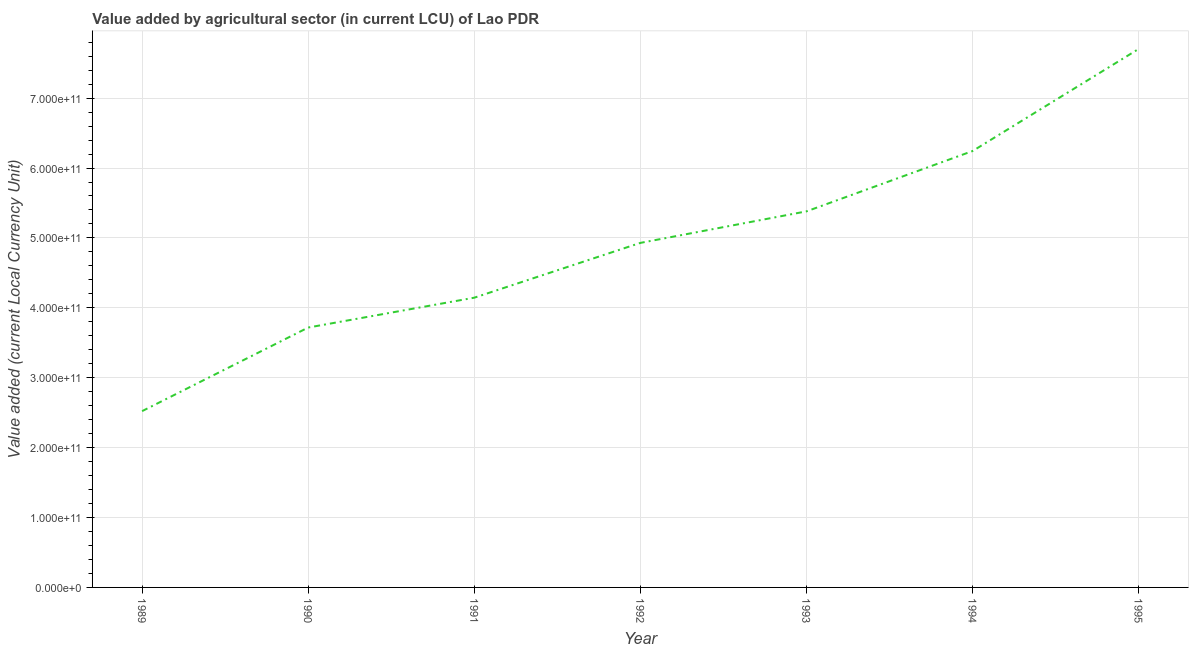What is the value added by agriculture sector in 1992?
Make the answer very short. 4.93e+11. Across all years, what is the maximum value added by agriculture sector?
Keep it short and to the point. 7.70e+11. Across all years, what is the minimum value added by agriculture sector?
Provide a short and direct response. 2.52e+11. In which year was the value added by agriculture sector maximum?
Make the answer very short. 1995. What is the sum of the value added by agriculture sector?
Provide a short and direct response. 3.46e+12. What is the difference between the value added by agriculture sector in 1989 and 1990?
Make the answer very short. -1.20e+11. What is the average value added by agriculture sector per year?
Keep it short and to the point. 4.95e+11. What is the median value added by agriculture sector?
Your answer should be very brief. 4.93e+11. In how many years, is the value added by agriculture sector greater than 420000000000 LCU?
Offer a very short reply. 4. Do a majority of the years between 1994 and 1991 (inclusive) have value added by agriculture sector greater than 100000000000 LCU?
Provide a short and direct response. Yes. What is the ratio of the value added by agriculture sector in 1989 to that in 1995?
Provide a succinct answer. 0.33. What is the difference between the highest and the second highest value added by agriculture sector?
Your answer should be very brief. 1.46e+11. Is the sum of the value added by agriculture sector in 1991 and 1993 greater than the maximum value added by agriculture sector across all years?
Keep it short and to the point. Yes. What is the difference between the highest and the lowest value added by agriculture sector?
Your response must be concise. 5.18e+11. In how many years, is the value added by agriculture sector greater than the average value added by agriculture sector taken over all years?
Your answer should be very brief. 3. How many lines are there?
Give a very brief answer. 1. What is the difference between two consecutive major ticks on the Y-axis?
Keep it short and to the point. 1.00e+11. Does the graph contain grids?
Your answer should be compact. Yes. What is the title of the graph?
Give a very brief answer. Value added by agricultural sector (in current LCU) of Lao PDR. What is the label or title of the X-axis?
Your answer should be compact. Year. What is the label or title of the Y-axis?
Your answer should be compact. Value added (current Local Currency Unit). What is the Value added (current Local Currency Unit) in 1989?
Your response must be concise. 2.52e+11. What is the Value added (current Local Currency Unit) in 1990?
Keep it short and to the point. 3.72e+11. What is the Value added (current Local Currency Unit) of 1991?
Ensure brevity in your answer.  4.14e+11. What is the Value added (current Local Currency Unit) in 1992?
Keep it short and to the point. 4.93e+11. What is the Value added (current Local Currency Unit) of 1993?
Your answer should be compact. 5.38e+11. What is the Value added (current Local Currency Unit) of 1994?
Your answer should be very brief. 6.24e+11. What is the Value added (current Local Currency Unit) in 1995?
Make the answer very short. 7.70e+11. What is the difference between the Value added (current Local Currency Unit) in 1989 and 1990?
Provide a succinct answer. -1.20e+11. What is the difference between the Value added (current Local Currency Unit) in 1989 and 1991?
Keep it short and to the point. -1.62e+11. What is the difference between the Value added (current Local Currency Unit) in 1989 and 1992?
Make the answer very short. -2.41e+11. What is the difference between the Value added (current Local Currency Unit) in 1989 and 1993?
Make the answer very short. -2.86e+11. What is the difference between the Value added (current Local Currency Unit) in 1989 and 1994?
Ensure brevity in your answer.  -3.72e+11. What is the difference between the Value added (current Local Currency Unit) in 1989 and 1995?
Offer a very short reply. -5.18e+11. What is the difference between the Value added (current Local Currency Unit) in 1990 and 1991?
Offer a very short reply. -4.27e+1. What is the difference between the Value added (current Local Currency Unit) in 1990 and 1992?
Make the answer very short. -1.21e+11. What is the difference between the Value added (current Local Currency Unit) in 1990 and 1993?
Ensure brevity in your answer.  -1.66e+11. What is the difference between the Value added (current Local Currency Unit) in 1990 and 1994?
Give a very brief answer. -2.52e+11. What is the difference between the Value added (current Local Currency Unit) in 1990 and 1995?
Give a very brief answer. -3.99e+11. What is the difference between the Value added (current Local Currency Unit) in 1991 and 1992?
Ensure brevity in your answer.  -7.84e+1. What is the difference between the Value added (current Local Currency Unit) in 1991 and 1993?
Provide a succinct answer. -1.24e+11. What is the difference between the Value added (current Local Currency Unit) in 1991 and 1994?
Provide a short and direct response. -2.10e+11. What is the difference between the Value added (current Local Currency Unit) in 1991 and 1995?
Offer a very short reply. -3.56e+11. What is the difference between the Value added (current Local Currency Unit) in 1992 and 1993?
Your answer should be compact. -4.51e+1. What is the difference between the Value added (current Local Currency Unit) in 1992 and 1994?
Keep it short and to the point. -1.31e+11. What is the difference between the Value added (current Local Currency Unit) in 1992 and 1995?
Offer a terse response. -2.77e+11. What is the difference between the Value added (current Local Currency Unit) in 1993 and 1994?
Your answer should be very brief. -8.63e+1. What is the difference between the Value added (current Local Currency Unit) in 1993 and 1995?
Offer a very short reply. -2.32e+11. What is the difference between the Value added (current Local Currency Unit) in 1994 and 1995?
Your response must be concise. -1.46e+11. What is the ratio of the Value added (current Local Currency Unit) in 1989 to that in 1990?
Your answer should be very brief. 0.68. What is the ratio of the Value added (current Local Currency Unit) in 1989 to that in 1991?
Give a very brief answer. 0.61. What is the ratio of the Value added (current Local Currency Unit) in 1989 to that in 1992?
Offer a terse response. 0.51. What is the ratio of the Value added (current Local Currency Unit) in 1989 to that in 1993?
Offer a very short reply. 0.47. What is the ratio of the Value added (current Local Currency Unit) in 1989 to that in 1994?
Ensure brevity in your answer.  0.4. What is the ratio of the Value added (current Local Currency Unit) in 1989 to that in 1995?
Ensure brevity in your answer.  0.33. What is the ratio of the Value added (current Local Currency Unit) in 1990 to that in 1991?
Keep it short and to the point. 0.9. What is the ratio of the Value added (current Local Currency Unit) in 1990 to that in 1992?
Your answer should be compact. 0.75. What is the ratio of the Value added (current Local Currency Unit) in 1990 to that in 1993?
Provide a succinct answer. 0.69. What is the ratio of the Value added (current Local Currency Unit) in 1990 to that in 1994?
Provide a short and direct response. 0.6. What is the ratio of the Value added (current Local Currency Unit) in 1990 to that in 1995?
Your answer should be compact. 0.48. What is the ratio of the Value added (current Local Currency Unit) in 1991 to that in 1992?
Your answer should be compact. 0.84. What is the ratio of the Value added (current Local Currency Unit) in 1991 to that in 1993?
Provide a short and direct response. 0.77. What is the ratio of the Value added (current Local Currency Unit) in 1991 to that in 1994?
Give a very brief answer. 0.66. What is the ratio of the Value added (current Local Currency Unit) in 1991 to that in 1995?
Provide a short and direct response. 0.54. What is the ratio of the Value added (current Local Currency Unit) in 1992 to that in 1993?
Ensure brevity in your answer.  0.92. What is the ratio of the Value added (current Local Currency Unit) in 1992 to that in 1994?
Make the answer very short. 0.79. What is the ratio of the Value added (current Local Currency Unit) in 1992 to that in 1995?
Provide a succinct answer. 0.64. What is the ratio of the Value added (current Local Currency Unit) in 1993 to that in 1994?
Offer a very short reply. 0.86. What is the ratio of the Value added (current Local Currency Unit) in 1993 to that in 1995?
Offer a very short reply. 0.7. What is the ratio of the Value added (current Local Currency Unit) in 1994 to that in 1995?
Your answer should be compact. 0.81. 